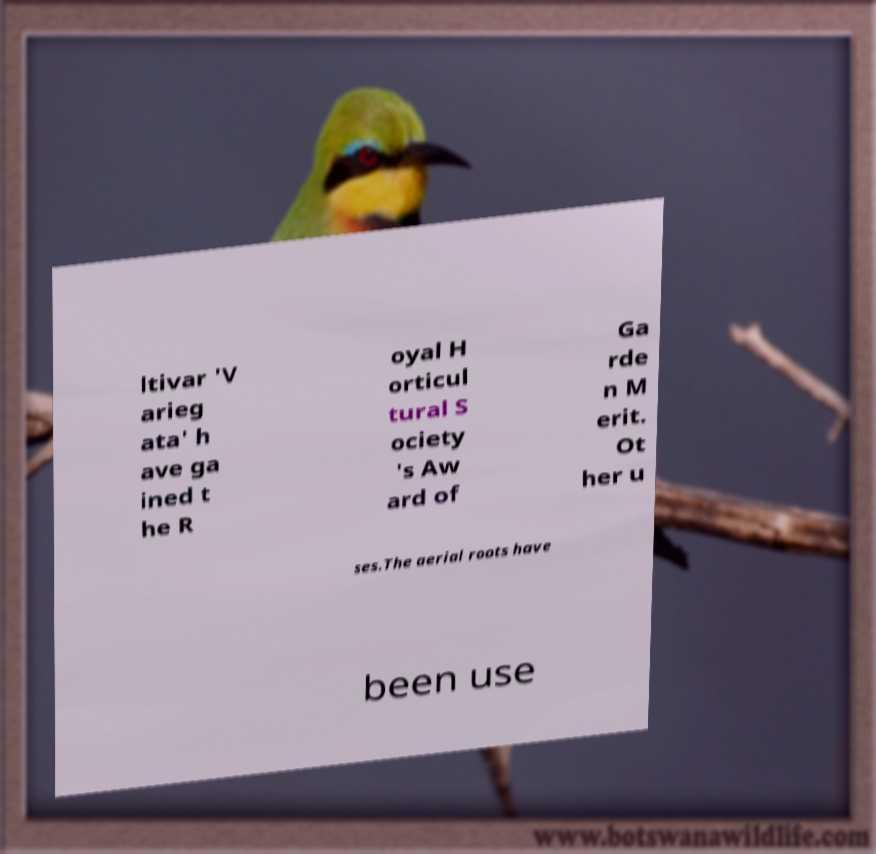Can you accurately transcribe the text from the provided image for me? ltivar 'V arieg ata' h ave ga ined t he R oyal H orticul tural S ociety 's Aw ard of Ga rde n M erit. Ot her u ses.The aerial roots have been use 